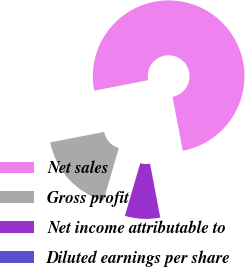<chart> <loc_0><loc_0><loc_500><loc_500><pie_chart><fcel>Net sales<fcel>Gross profit<fcel>Net income attributable to<fcel>Diluted earnings per share<nl><fcel>75.06%<fcel>17.43%<fcel>7.51%<fcel>0.0%<nl></chart> 